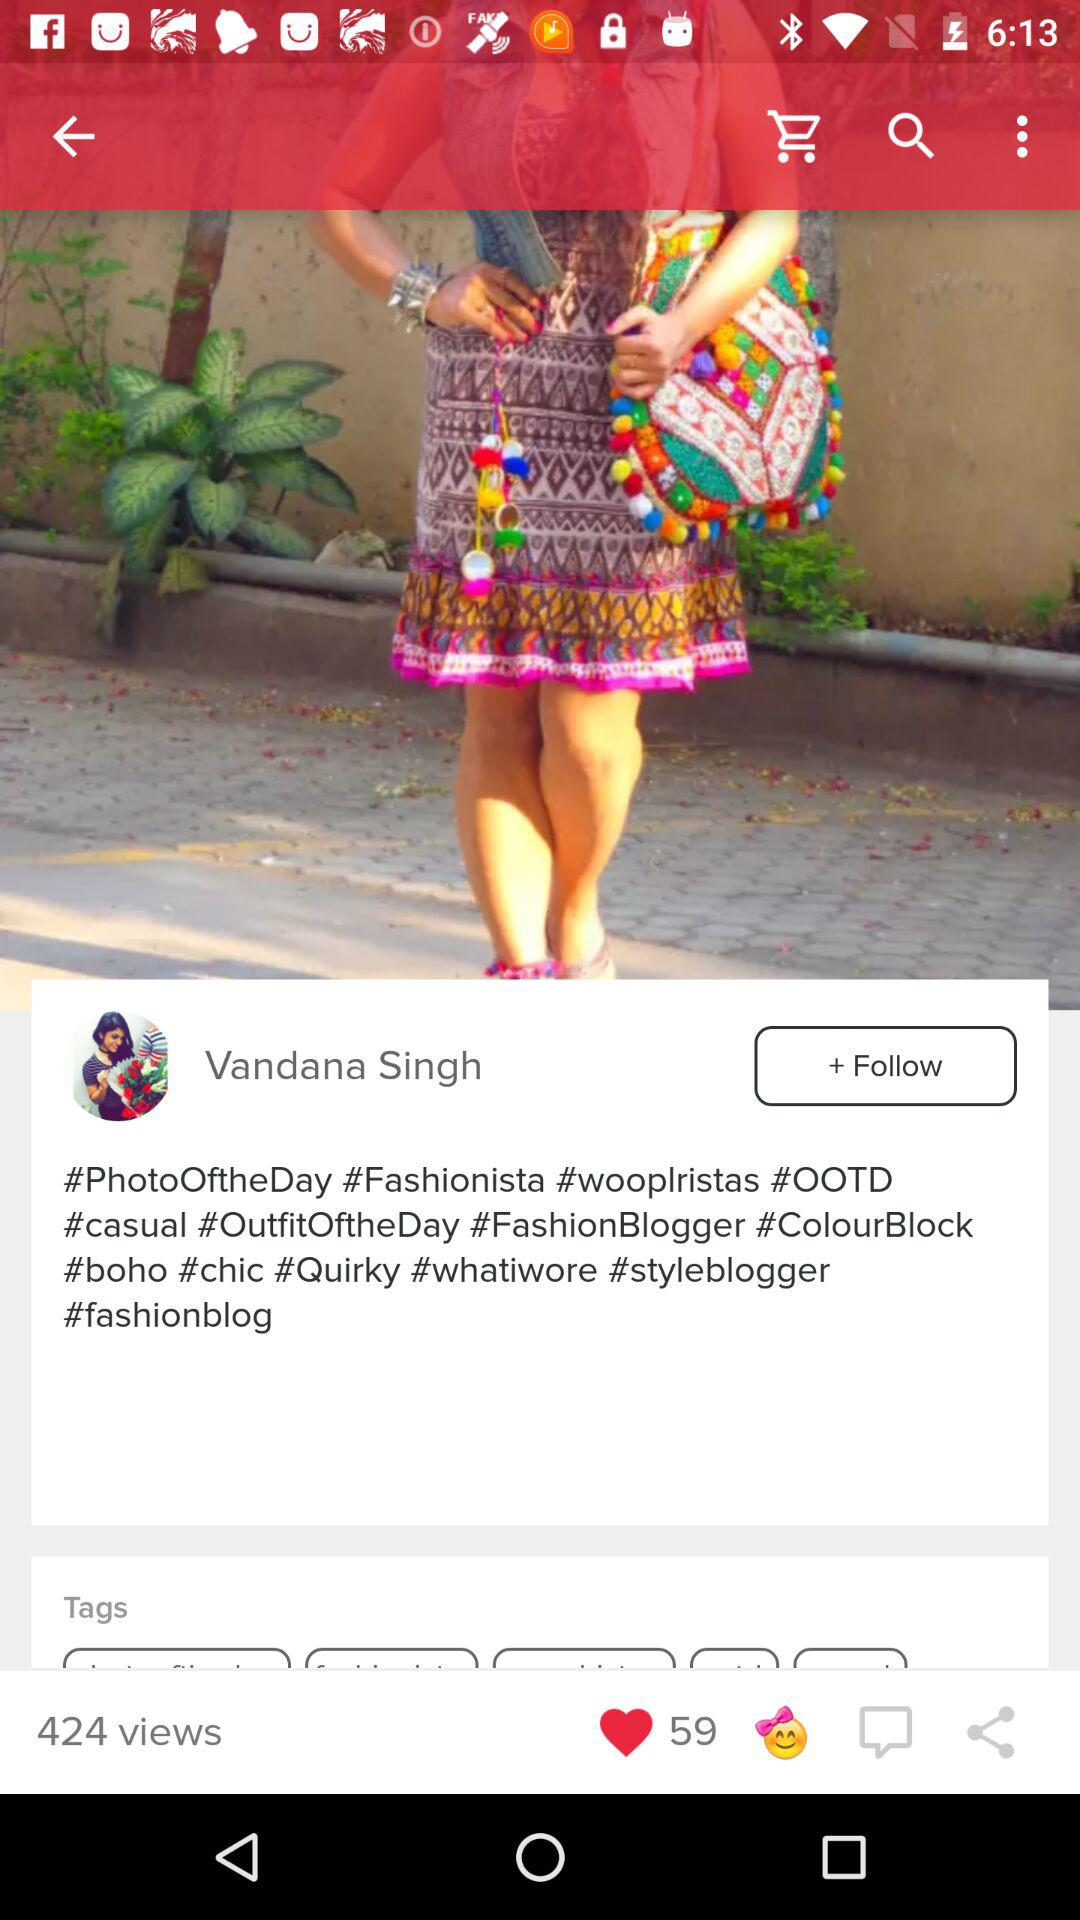How many people are following Vandana Singh?
When the provided information is insufficient, respond with <no answer>. <no answer> 